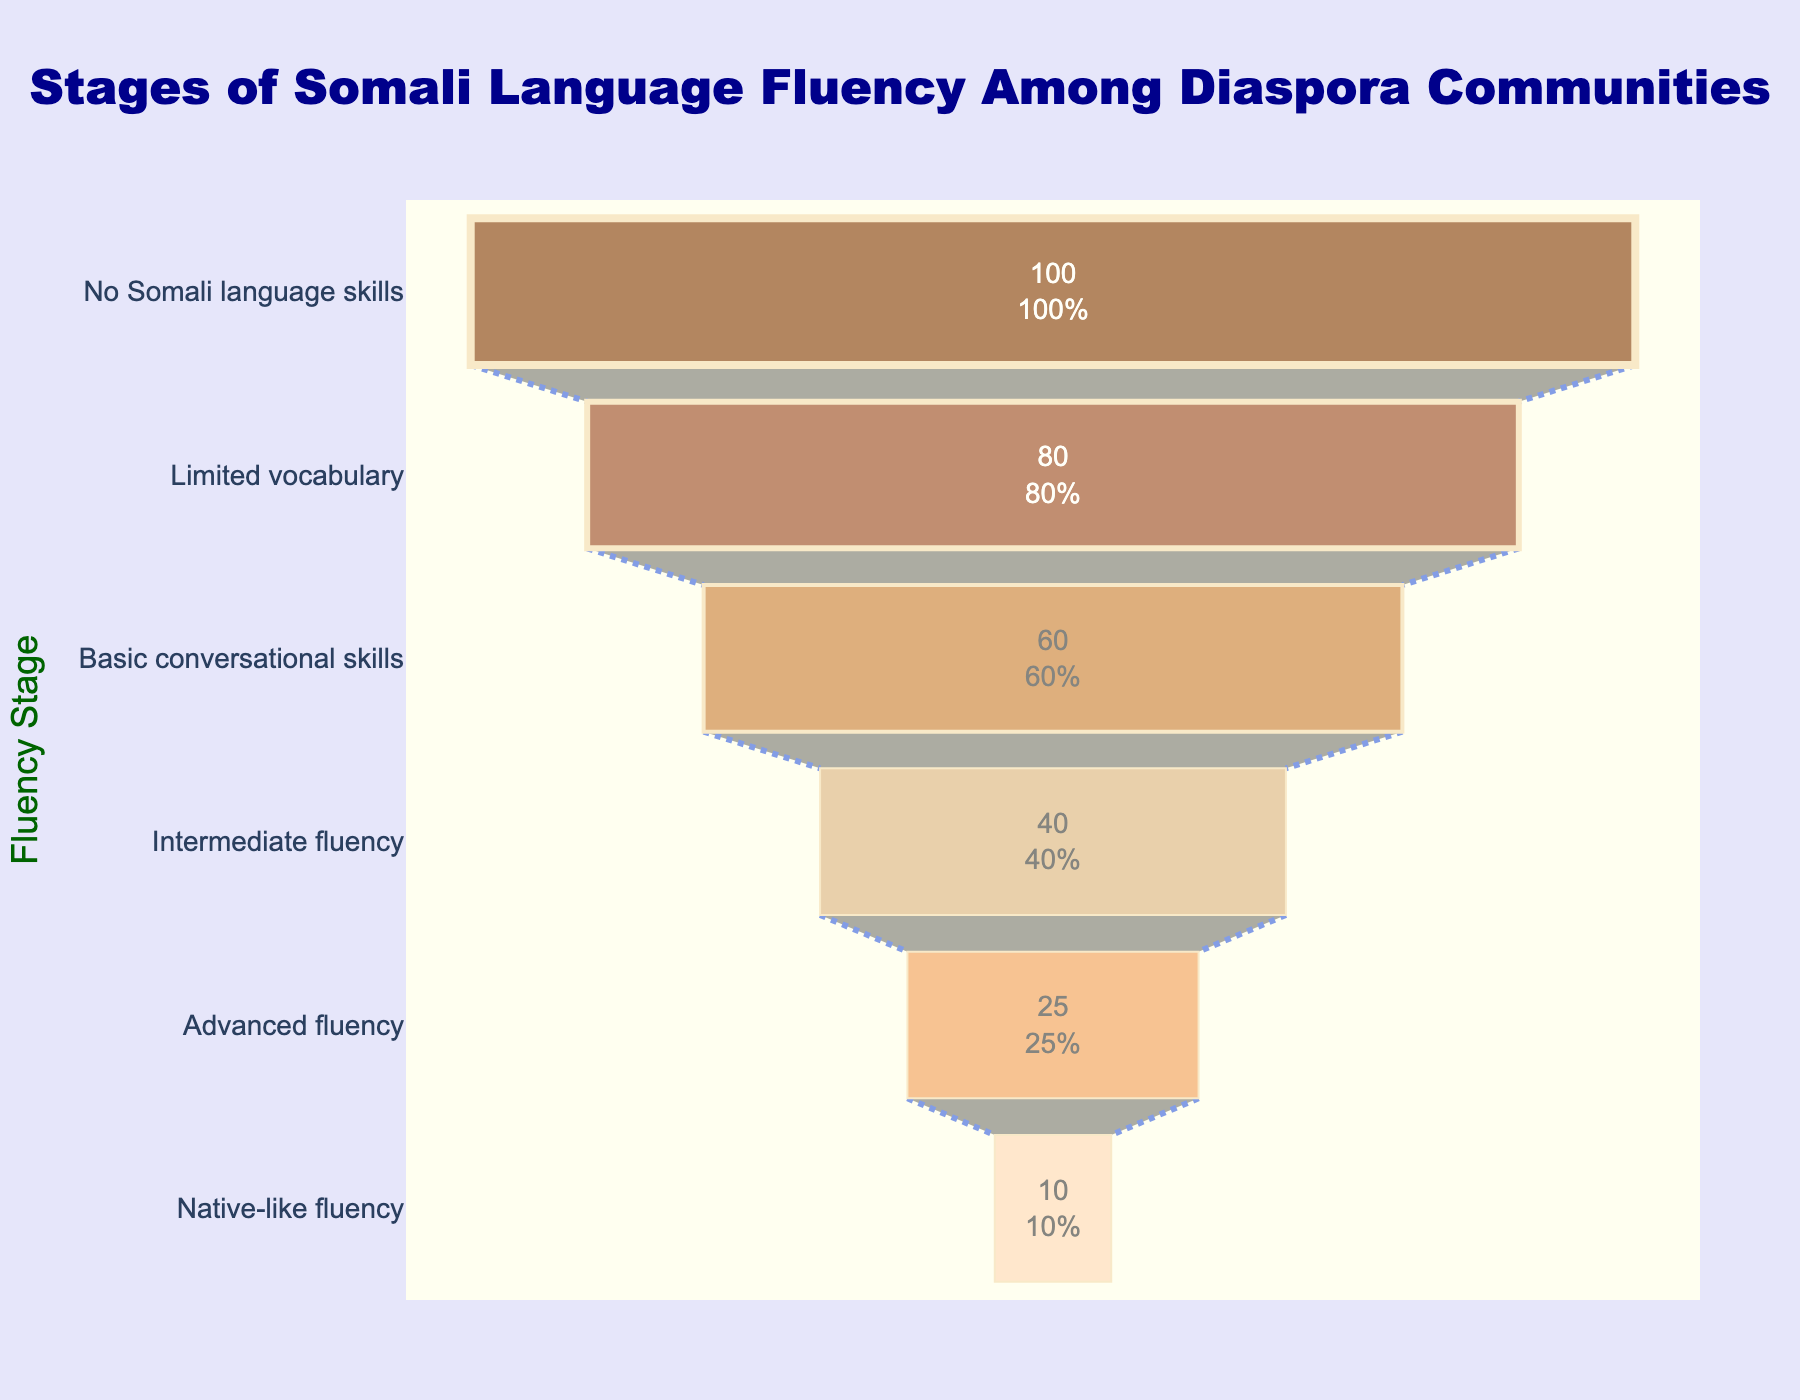What is the title of the funnel chart? The title of the plot is prominently displayed at the top in a large blue font.
Answer: Stages of Somali Language Fluency Among Diaspora Communities How many stages of fluency are shown in the chart? Counting each entry in the y-axis, we observe that there are six stages of fluency listed.
Answer: Six stages Which fluency stage has the highest percentage? The highest bar on the x-axis corresponds to the "No Somali language skills" stage, which is at 100%.
Answer: No Somali language skills What percentage of the diaspora community has native-like fluency? Looking at the smallest portion of the funnel representing "Native-like fluency," we see the percentage labeled as 10%.
Answer: 10% How many stages have a percentage equal to or greater than 50%? By examining the x-axis values, we note that "Limited vocabulary" (80%) and "No Somali language skills" (100%) are equal to or above 50%.
Answer: Two stages What is the difference in percentage between those with native-like fluency and those with advanced fluency? Subtract the percentage of "Native-like fluency" (10%) from "Advanced fluency" (25%), which gives us 25% - 10%.
Answer: 15% What is the sum of the percentages of basic conversational skills and intermediate fluency? Adding the percentages for "Basic conversational skills" (60%) and "Intermediate fluency" (40%) gives us 60% + 40%.
Answer: 100% Which stage has a percentage lower than 20%? By examining the x-axis values, we find that "Native-like fluency" is the only stage with a percentage below 20%.
Answer: Native-like fluency Compare the percentages of the top two stages. Which one has a greater value and by how much? The top two stages are "No Somali language skills" (100%) and "Limited vocabulary" (80%). Subtracting 80% from 100% gives us the difference.
Answer: No Somali language skills, by 20% What is the average percentage across all stages? Sum all percentage values (10% + 25% + 40% + 60% + 80% + 100%) and divide by the number of stages (6). The sum is 315%, and the average is 315/6.
Answer: 52.5% 